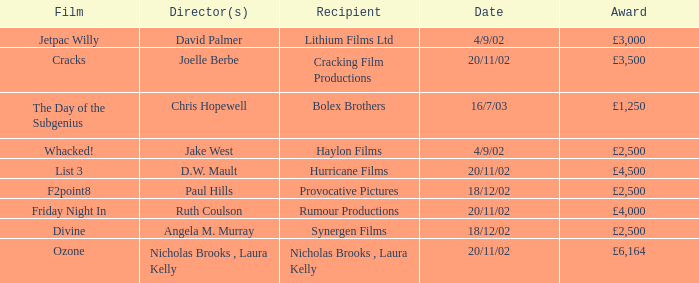Who earned a £3,000 prize on the 9th of april, 2002? Lithium Films Ltd. 